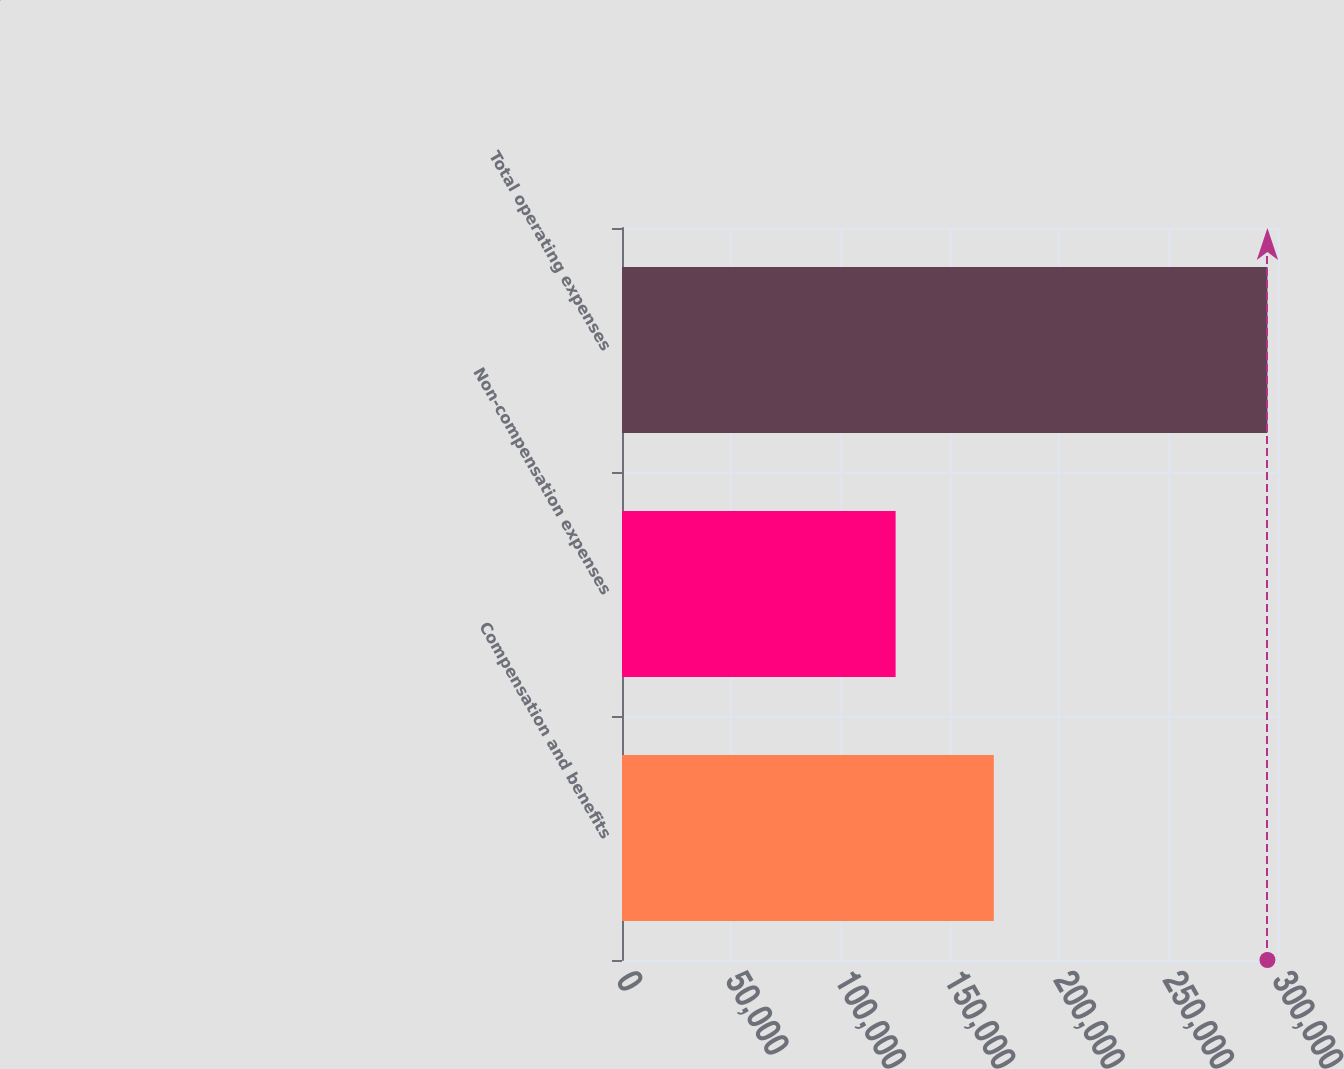<chart> <loc_0><loc_0><loc_500><loc_500><bar_chart><fcel>Compensation and benefits<fcel>Non-compensation expenses<fcel>Total operating expenses<nl><fcel>170036<fcel>125135<fcel>295171<nl></chart> 